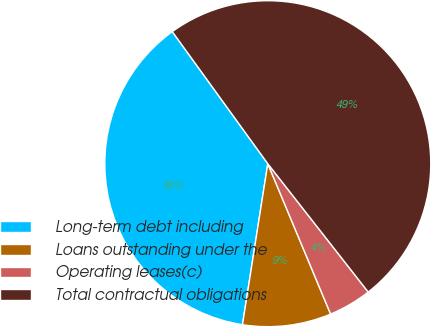Convert chart. <chart><loc_0><loc_0><loc_500><loc_500><pie_chart><fcel>Long-term debt including<fcel>Loans outstanding under the<fcel>Operating leases(c)<fcel>Total contractual obligations<nl><fcel>37.55%<fcel>8.78%<fcel>4.27%<fcel>49.39%<nl></chart> 